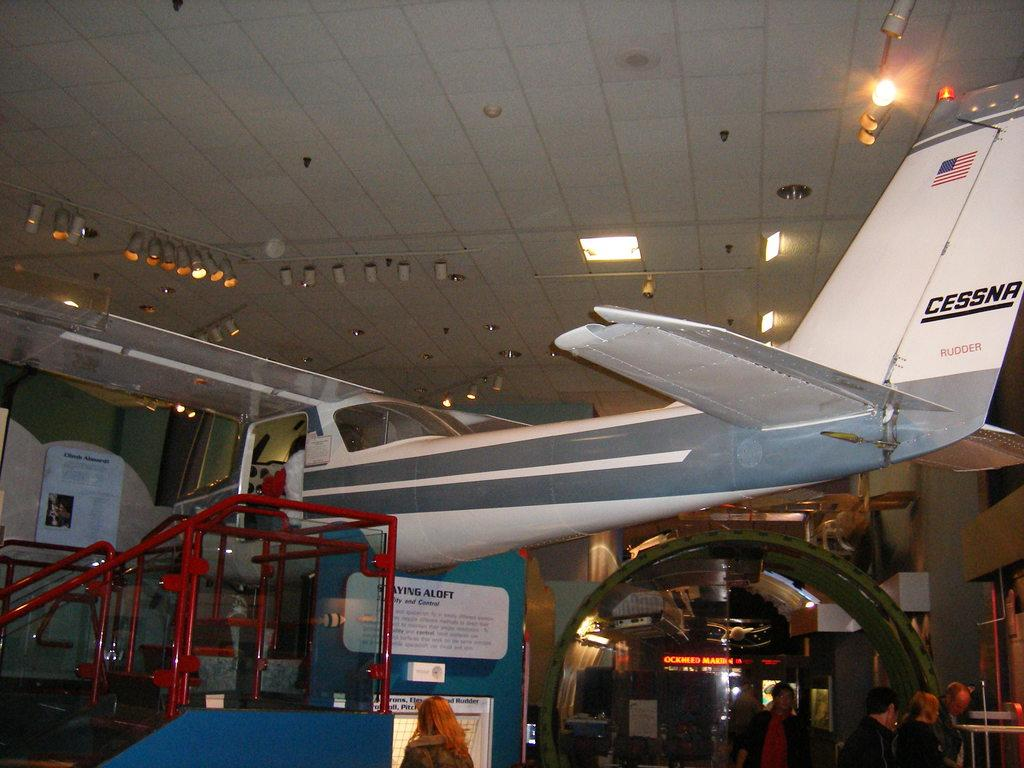<image>
Create a compact narrative representing the image presented. A plane which is marked Cessna on its tailfin is on display. 